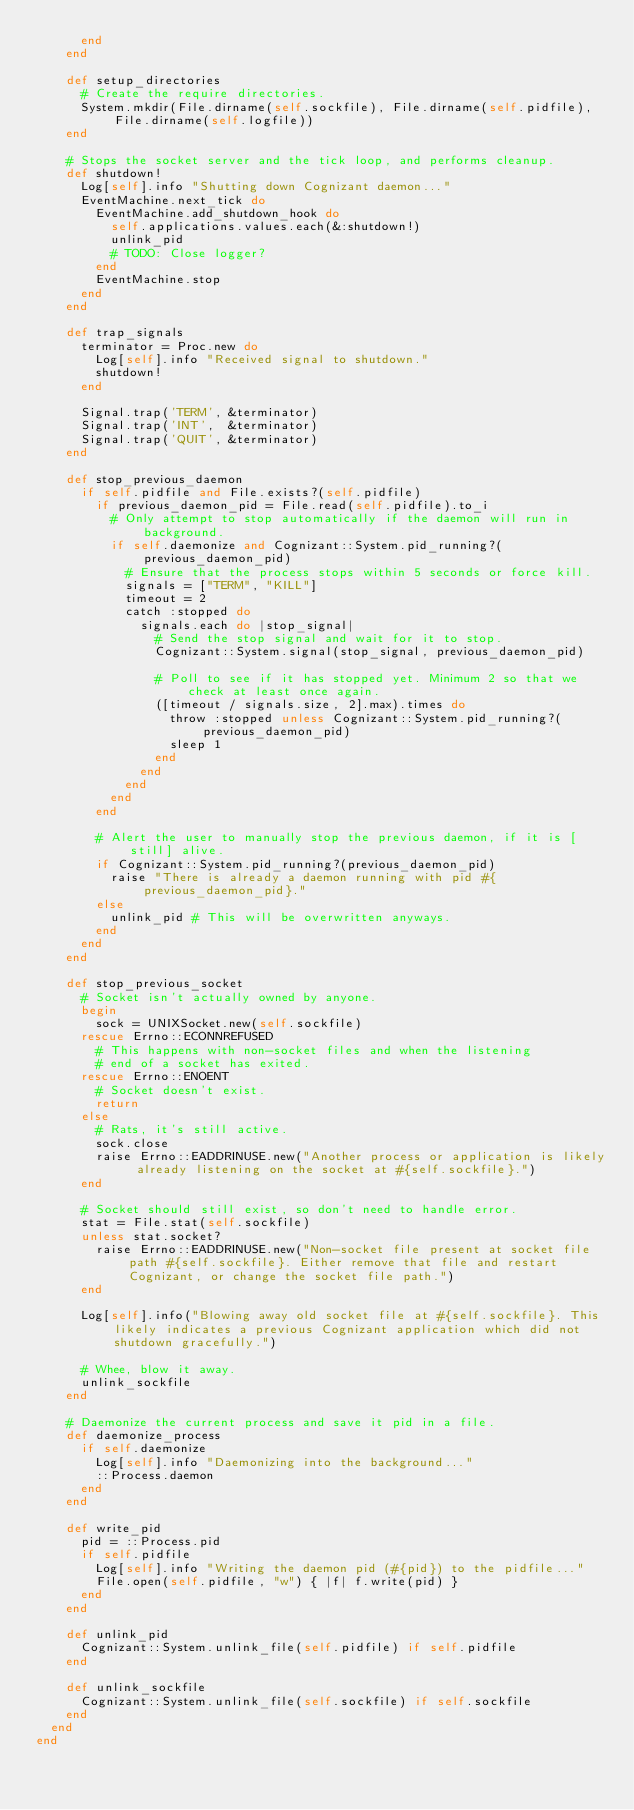Convert code to text. <code><loc_0><loc_0><loc_500><loc_500><_Ruby_>      end
    end

    def setup_directories
      # Create the require directories.
      System.mkdir(File.dirname(self.sockfile), File.dirname(self.pidfile), File.dirname(self.logfile))
    end

    # Stops the socket server and the tick loop, and performs cleanup.
    def shutdown!
      Log[self].info "Shutting down Cognizant daemon..."
      EventMachine.next_tick do
        EventMachine.add_shutdown_hook do
          self.applications.values.each(&:shutdown!)
          unlink_pid
          # TODO: Close logger?
        end
        EventMachine.stop
      end
    end

    def trap_signals
      terminator = Proc.new do
        Log[self].info "Received signal to shutdown."
        shutdown!
      end

      Signal.trap('TERM', &terminator)
      Signal.trap('INT',  &terminator)
      Signal.trap('QUIT', &terminator)
    end

    def stop_previous_daemon
      if self.pidfile and File.exists?(self.pidfile)
        if previous_daemon_pid = File.read(self.pidfile).to_i
          # Only attempt to stop automatically if the daemon will run in background.
          if self.daemonize and Cognizant::System.pid_running?(previous_daemon_pid)
            # Ensure that the process stops within 5 seconds or force kill.
            signals = ["TERM", "KILL"]
            timeout = 2
            catch :stopped do
              signals.each do |stop_signal|
                # Send the stop signal and wait for it to stop.
                Cognizant::System.signal(stop_signal, previous_daemon_pid)

                # Poll to see if it has stopped yet. Minimum 2 so that we check at least once again.
                ([timeout / signals.size, 2].max).times do
                  throw :stopped unless Cognizant::System.pid_running?(previous_daemon_pid)
                  sleep 1
                end
              end
            end
          end
        end

        # Alert the user to manually stop the previous daemon, if it is [still] alive.
        if Cognizant::System.pid_running?(previous_daemon_pid)
          raise "There is already a daemon running with pid #{previous_daemon_pid}."
        else
          unlink_pid # This will be overwritten anyways.
        end
      end
    end

    def stop_previous_socket
      # Socket isn't actually owned by anyone.
      begin
        sock = UNIXSocket.new(self.sockfile)
      rescue Errno::ECONNREFUSED
        # This happens with non-socket files and when the listening
        # end of a socket has exited.
      rescue Errno::ENOENT
        # Socket doesn't exist.
        return
      else
        # Rats, it's still active.
        sock.close
        raise Errno::EADDRINUSE.new("Another process or application is likely already listening on the socket at #{self.sockfile}.")
      end
    
      # Socket should still exist, so don't need to handle error.
      stat = File.stat(self.sockfile)
      unless stat.socket?
        raise Errno::EADDRINUSE.new("Non-socket file present at socket file path #{self.sockfile}. Either remove that file and restart Cognizant, or change the socket file path.")
      end
    
      Log[self].info("Blowing away old socket file at #{self.sockfile}. This likely indicates a previous Cognizant application which did not shutdown gracefully.")

      # Whee, blow it away.
      unlink_sockfile
    end

    # Daemonize the current process and save it pid in a file.
    def daemonize_process
      if self.daemonize
        Log[self].info "Daemonizing into the background..."
        ::Process.daemon
      end
    end

    def write_pid
      pid = ::Process.pid
      if self.pidfile
        Log[self].info "Writing the daemon pid (#{pid}) to the pidfile..."
        File.open(self.pidfile, "w") { |f| f.write(pid) }
      end
    end

    def unlink_pid
      Cognizant::System.unlink_file(self.pidfile) if self.pidfile
    end

    def unlink_sockfile
      Cognizant::System.unlink_file(self.sockfile) if self.sockfile
    end
  end
end
</code> 